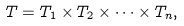Convert formula to latex. <formula><loc_0><loc_0><loc_500><loc_500>T = T _ { 1 } \times T _ { 2 } \times \cdots \times T _ { n } ,</formula> 